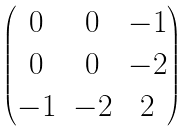<formula> <loc_0><loc_0><loc_500><loc_500>\begin{pmatrix} 0 & 0 & - 1 \\ 0 & 0 & - 2 \\ - 1 & - 2 & 2 \end{pmatrix}</formula> 